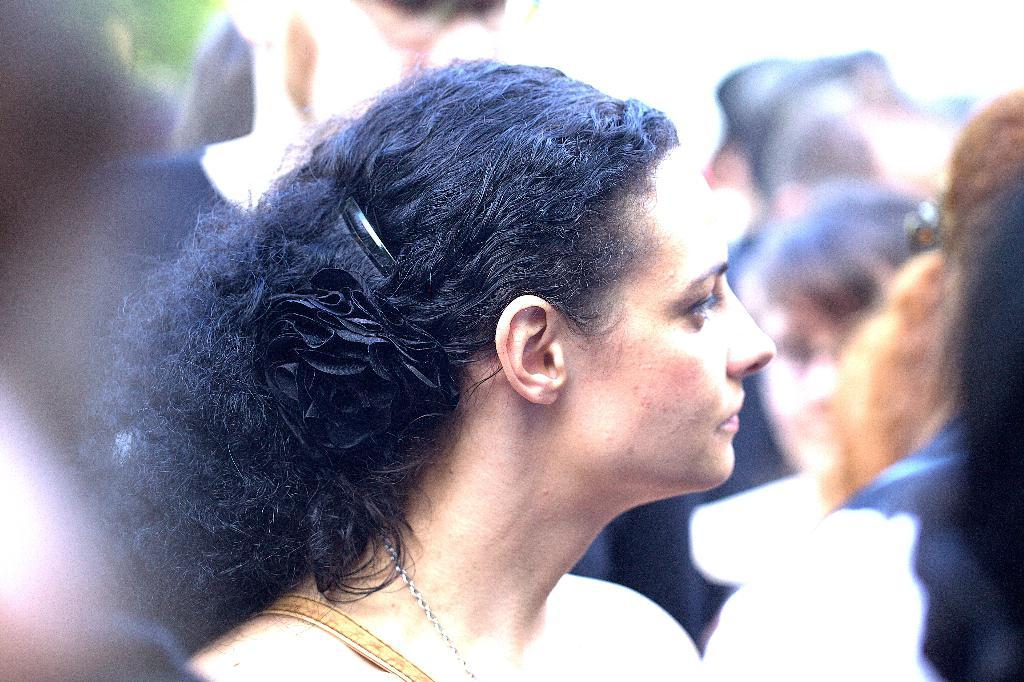Who is the main subject in the image? There is a woman in the image. Can you describe the other people in the image? There is a group of people in the image. What can be observed about the background of the image? The background of the image is blurry. What type of lipstick is the farmer wearing in the image? There is no farmer present in the image, and therefore no lipstick to describe. 